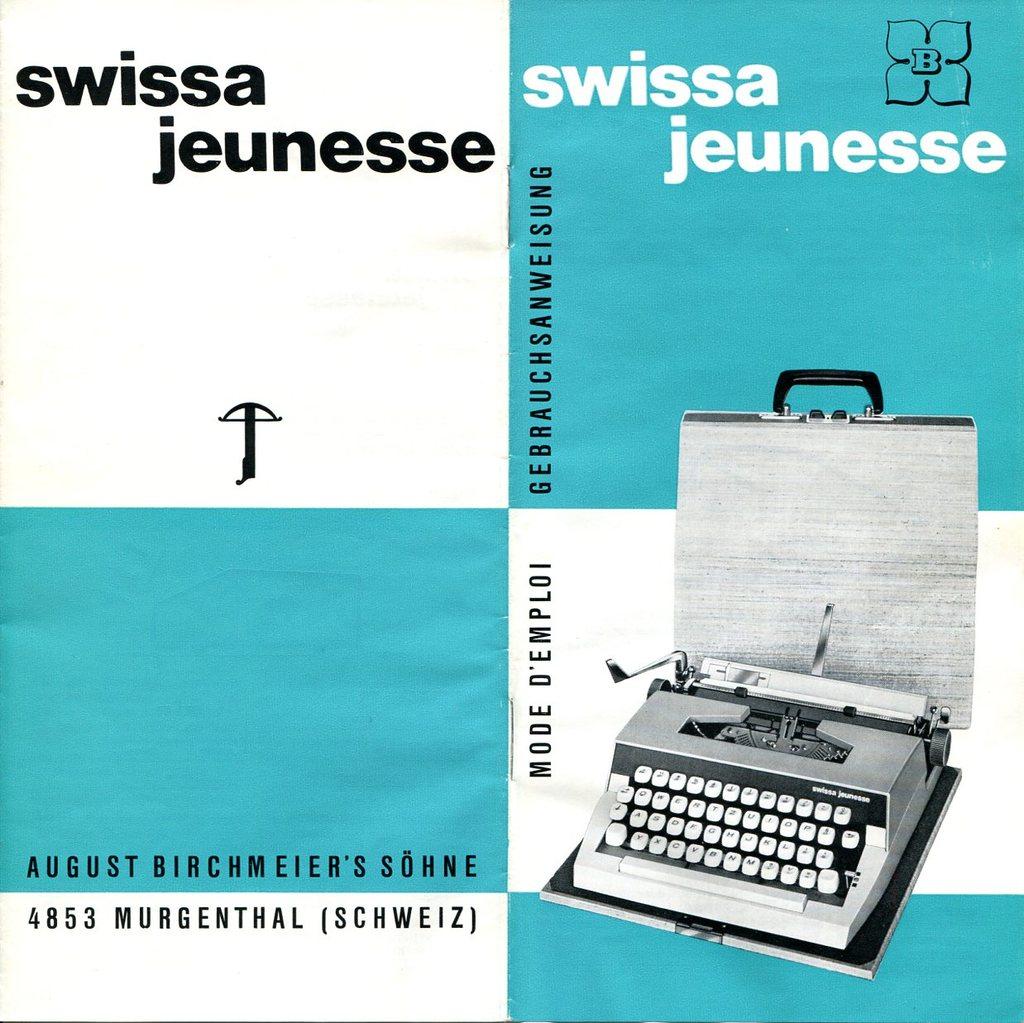What is written in parenthesis?
Offer a terse response. Schweiz. 